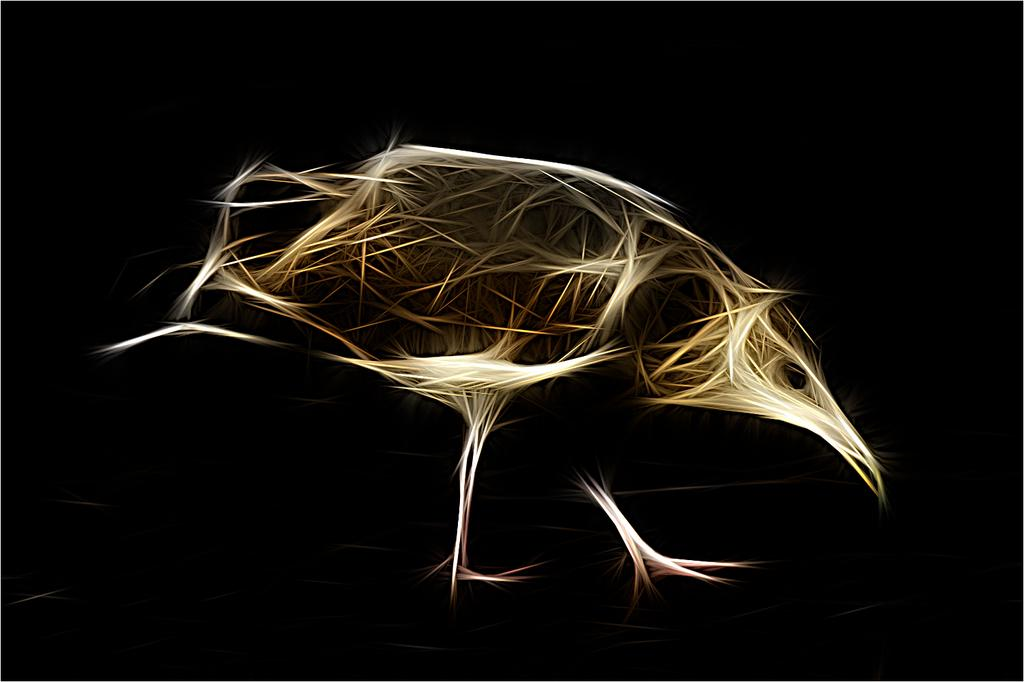What type of art is featured in the image? The image contains digital art. What is the main subject of the digital art? There is an animal shape in the art. What colors are used for the animal shape? The animal shape is cream and brown in color. What color is the background of the digital art? The background of the art is black. Can you tell me how many patches are on the bear's back in the image? There is no bear present in the image, and therefore no patches can be observed on its back. 